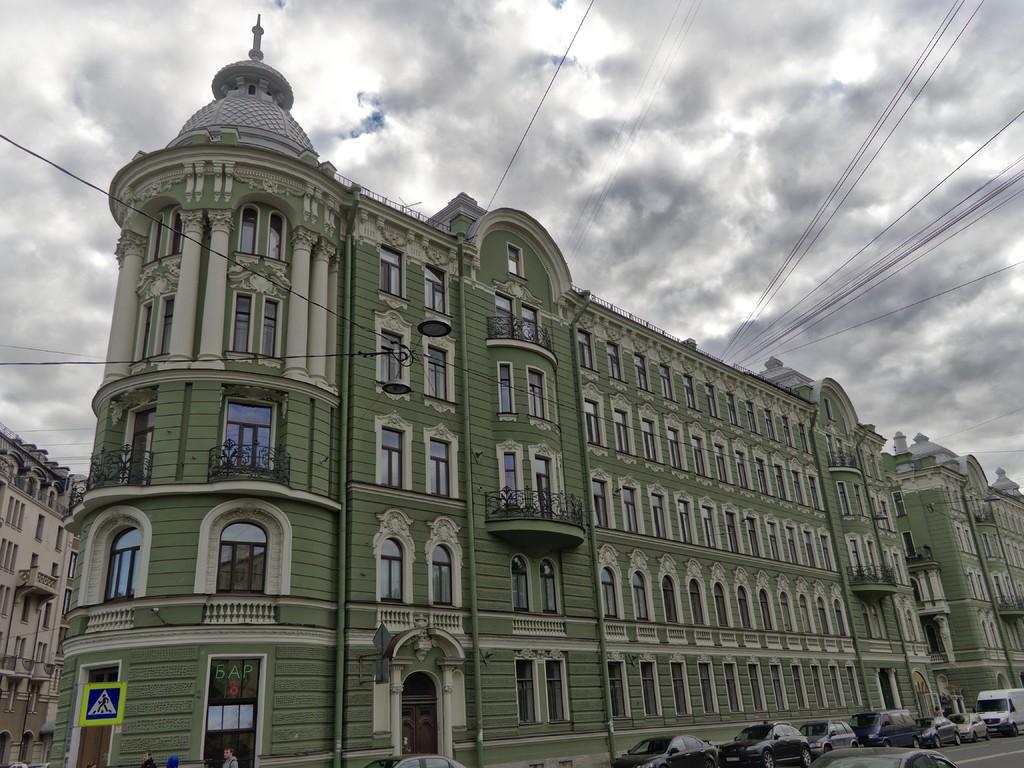Could you give a brief overview of what you see in this image? In this image we can see a building containing windows on it. To the right side of the image we can see group of cars placed on the road. In the background ,we can see a building and the sky. 